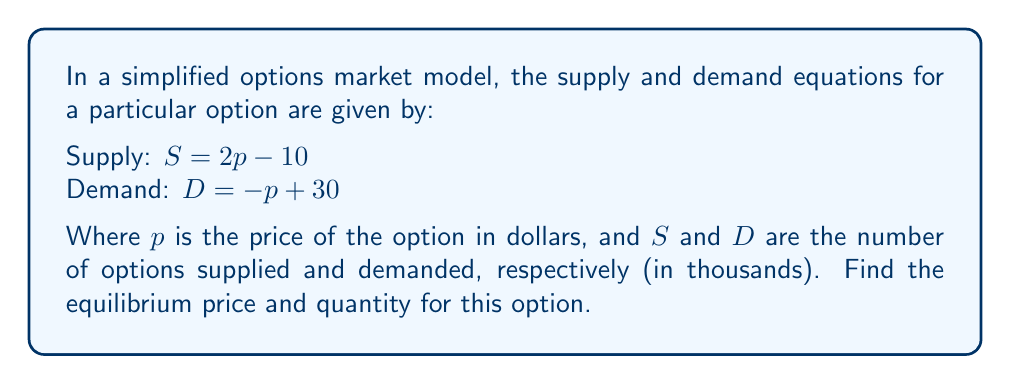Provide a solution to this math problem. To find the equilibrium point, we need to solve the system of equations where supply equals demand:

1) Set up the equation:
   $S = D$
   $2p - 10 = -p + 30$

2) Solve for $p$:
   $2p - 10 = -p + 30$
   $2p + p = 30 + 10$
   $3p = 40$
   $p = \frac{40}{3} \approx 13.33$

3) Calculate the equilibrium quantity by substituting $p$ into either the supply or demand equation:
   $S = 2(\frac{40}{3}) - 10 = \frac{80}{3} - 10 = \frac{80}{3} - \frac{30}{3} = \frac{50}{3} \approx 16.67$

Therefore, the equilibrium price is $\frac{40}{3}$ dollars, and the equilibrium quantity is $\frac{50}{3}$ thousand options.
Answer: Price: $\frac{40}{3}$ dollars, Quantity: $\frac{50}{3}$ thousand options 